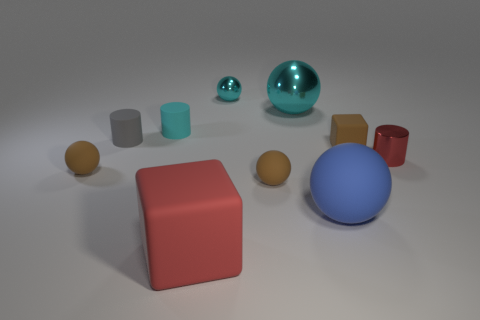Can you describe the smallest object in the scene? The smallest object in the scene is a small turquoise blue ball with a reflective surface. 